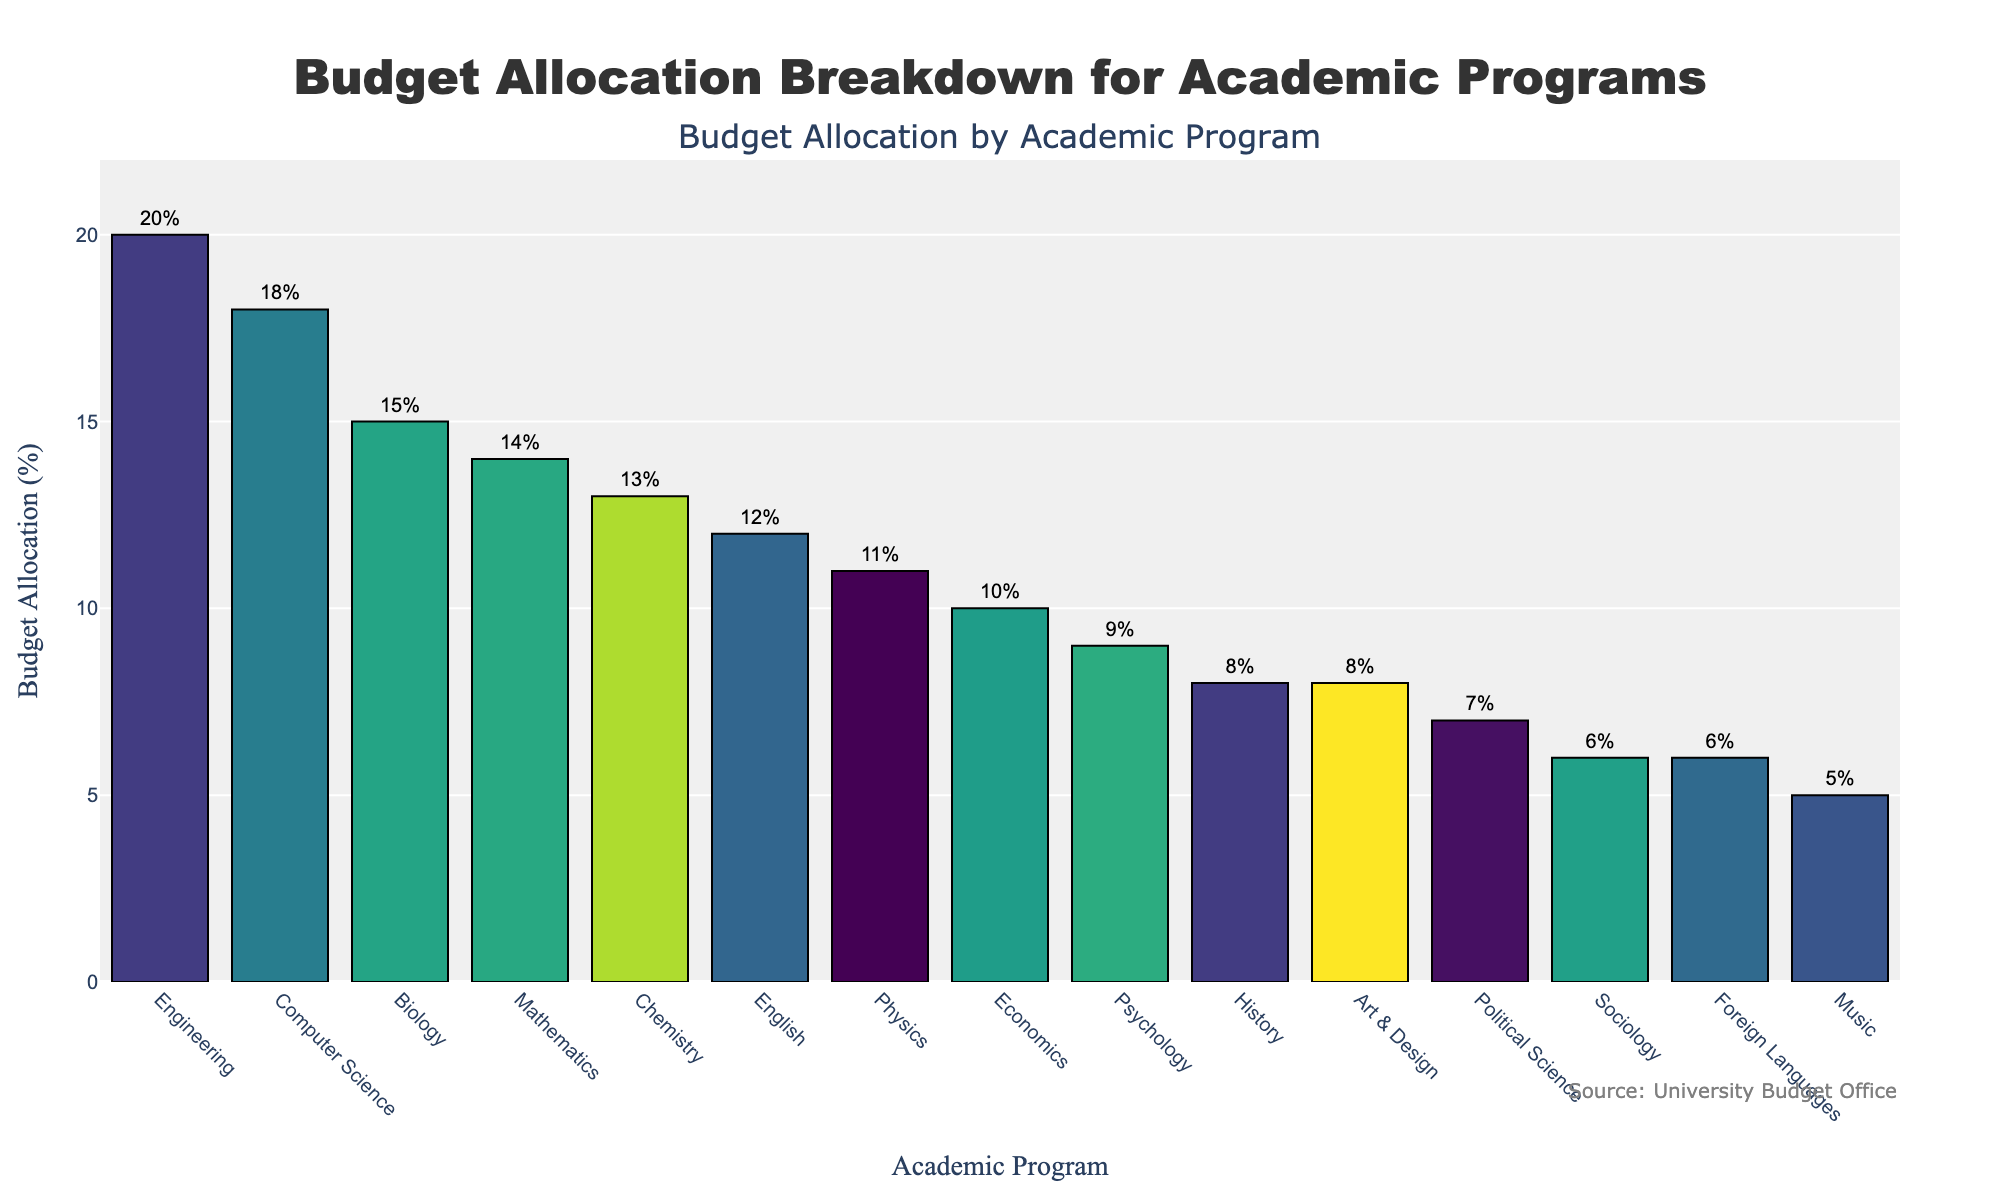What's the highest budget allocation and which program receives it? The bar chart shows the budget allocation for all academic programs. The highest bar represents the program with the highest allocation. In this chart, the program is Engineering with a budget allocation of 20%.
Answer: Engineering with 20% Which program has a lower budget allocation, Art & Design or Sociology? By comparing the heights of the bars for Art & Design and Sociology, we can see that Art & Design has an 8% allocation while Sociology has a 6% allocation. Therefore, Sociology has a lower budget allocation.
Answer: Sociology with 6% What is the total budget allocation for the Humanities programs (English, History, Foreign Languages)? To find the total budget allocation, sum up the percentages for English (12%), History (8%), and Foreign Languages (6%). Therefore, 12% + 8% + 6% = 26%.
Answer: 26% Compare the budget allocations for Science programs (Biology, Chemistry, Physics) and Engineering. Which one has the higher allocation? Summing up the allocations for Biology (15%), Chemistry (13%), and Physics (11%) gives 15% + 13% + 11% = 39%. Engineering has an allocation of 20%. Therefore, Science programs have a higher total allocation.
Answer: Science programs with 39% Which two programs have budget allocations closest to each other, and what are their allocations? Observing the chart, the programs Mathematics and Chemistry have closely aligned bars. Mathematics has a 14% allocation and Chemistry has a 13% allocation, making their allocations closest.
Answer: Mathematics with 14% and Chemistry with 13% What is the average budget allocation for all programs in the Social Sciences category (Psychology, Sociology, Political Science, Economics)? To calculate the average, first sum up the allocations for Psychology (9%), Sociology (6%), Political Science (7%), and Economics (10%), which is 9% + 6% + 7% + 10% = 32%. There are 4 programs, so the average allocation is 32% / 4 = 8%.
Answer: 8% Which program has a larger budget allocation, Computer Science or Biology, and by how much? By comparing the heights of the bars, Computer Science has an 18% allocation and Biology has a 15% allocation. The difference is 18% - 15% = 3%.
Answer: Computer Science by 3% Assess the visual difference in the budget allocation for Music and Engineering. Observing the chart, Music and Engineering bars differ greatly in height. Music has a 5% allocation, while Engineering has a 20% allocation, indicating a significant visual difference in their budget allocations.
Answer: Music 5%, Engineering 20% If we combine the budget allocations of all Arts programs (Art & Design and Music), how much is allocated? Art & Design has an 8% allocation and Music has a 5% allocation. Combined, the total allocation is 8% + 5% = 13%.
Answer: 13% 